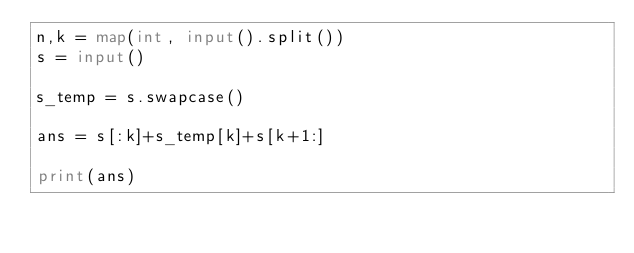Convert code to text. <code><loc_0><loc_0><loc_500><loc_500><_Python_>n,k = map(int, input().split())
s = input()

s_temp = s.swapcase()

ans = s[:k]+s_temp[k]+s[k+1:]

print(ans)</code> 